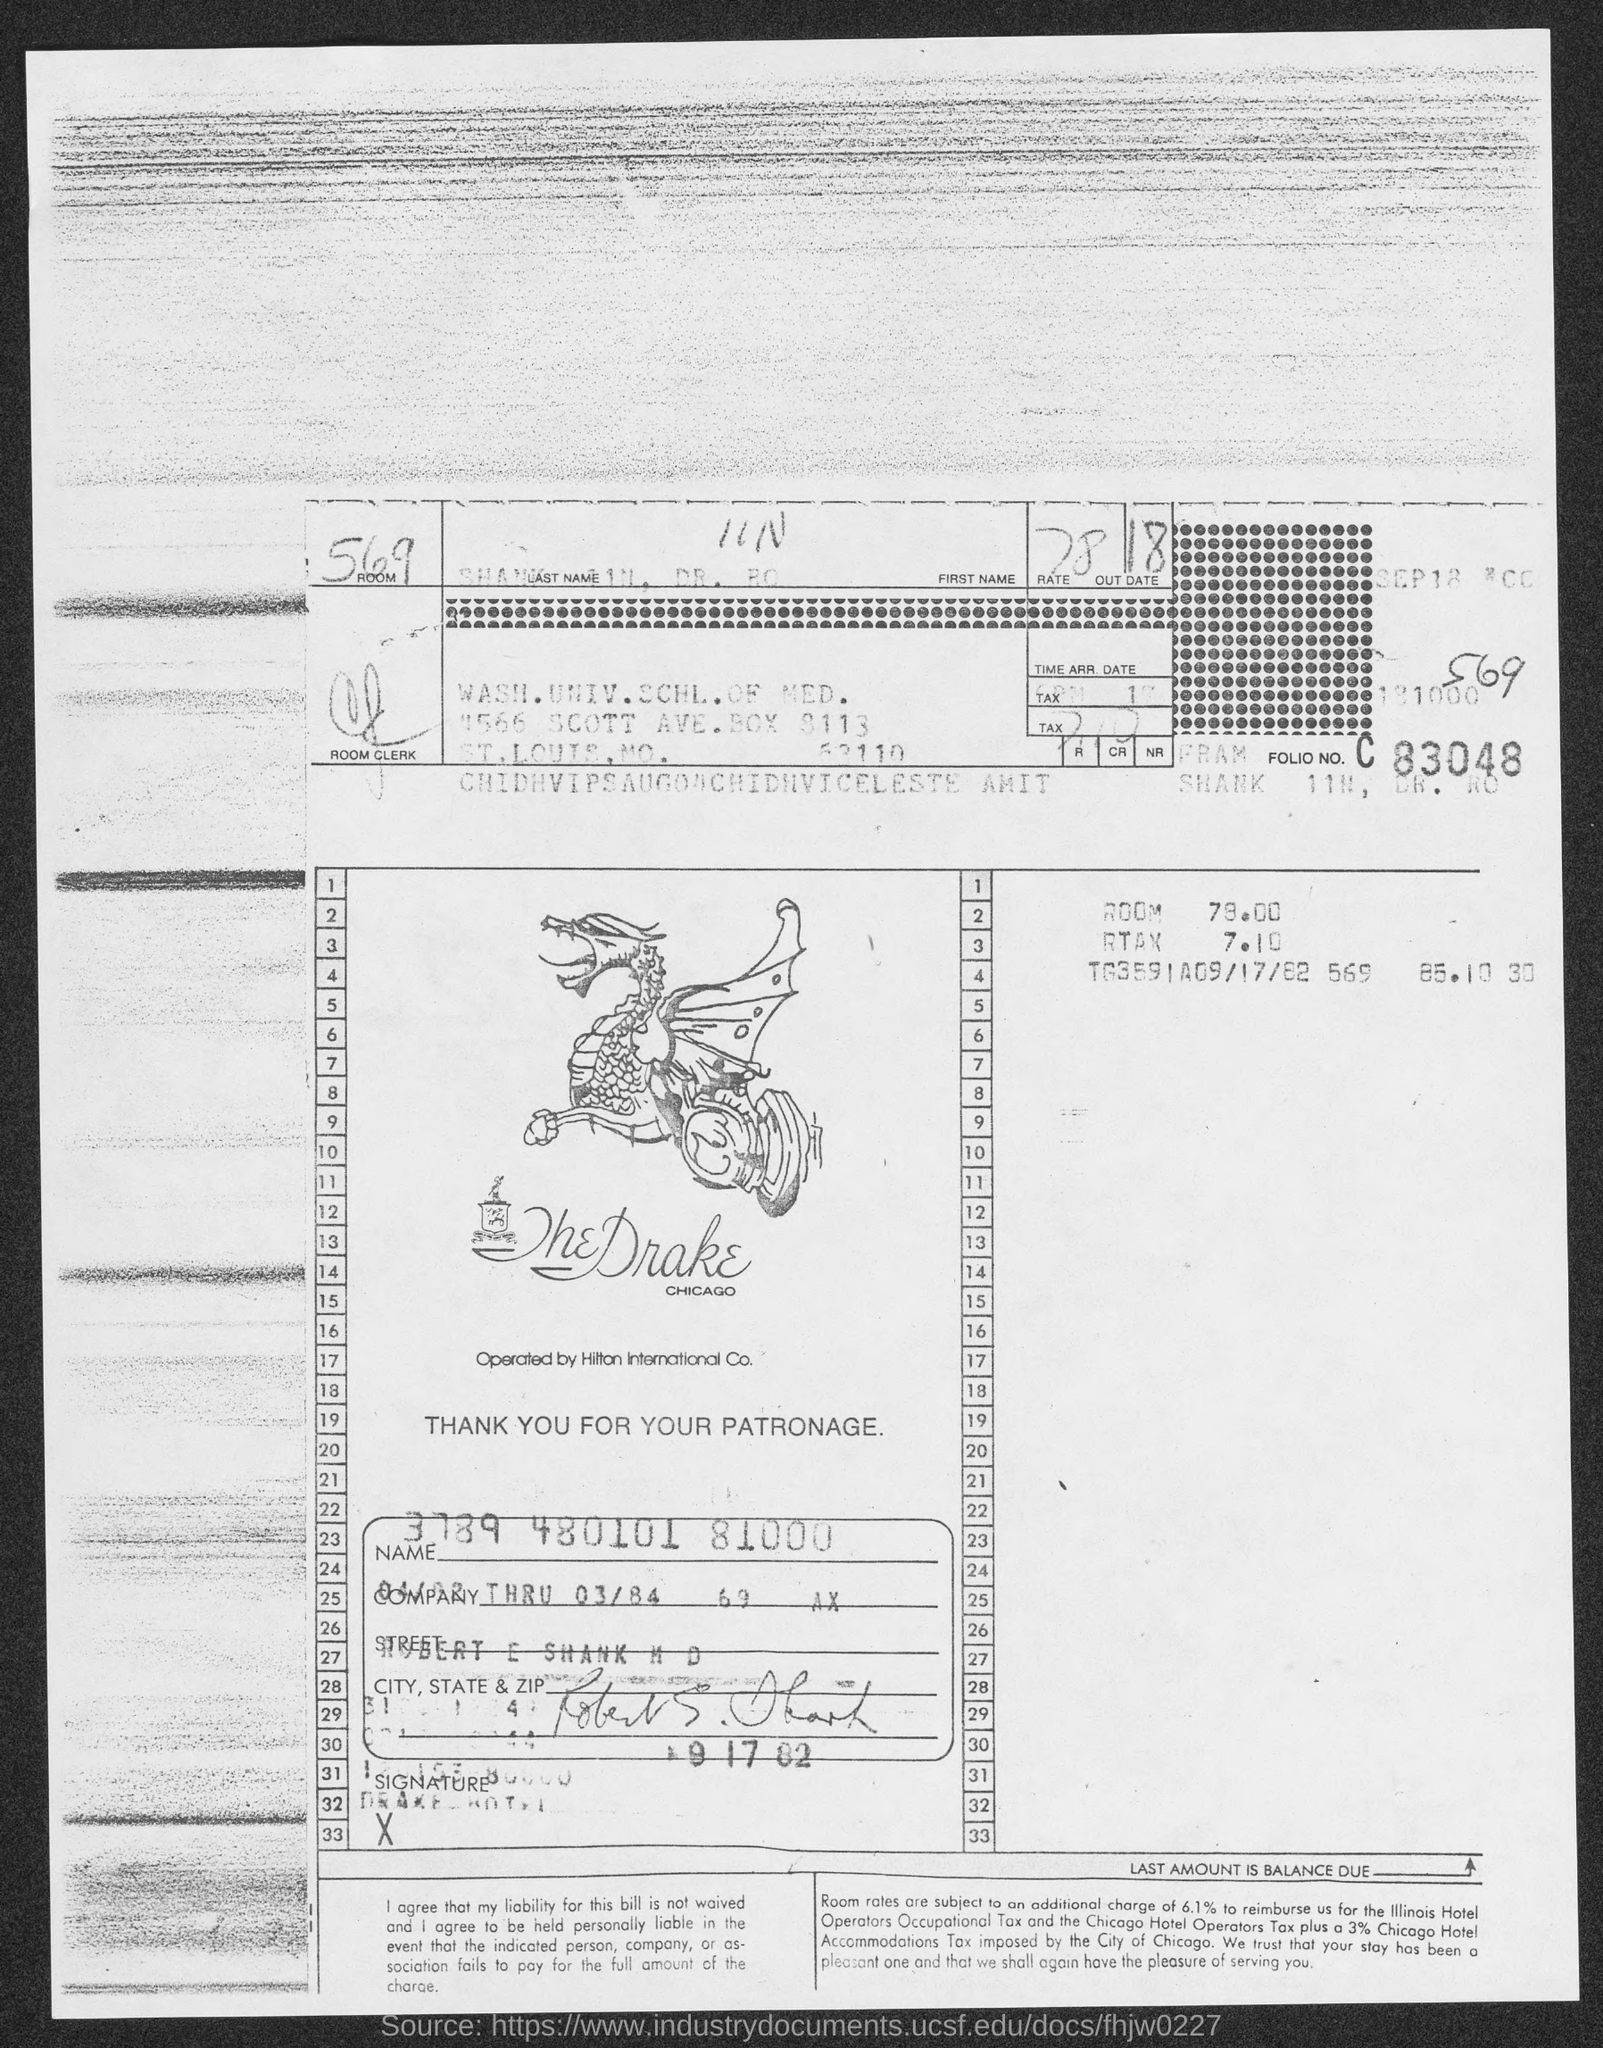What is the room no.?
Make the answer very short. 569. In which county is wash. univ. schl. of med. at?
Your answer should be very brief. St. Louis. 